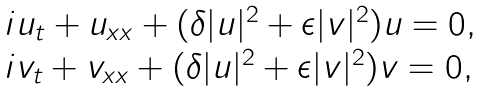Convert formula to latex. <formula><loc_0><loc_0><loc_500><loc_500>\begin{array} { l l } i u _ { t } + u _ { x x } + ( \delta | u | ^ { 2 } + \epsilon | v | ^ { 2 } ) u = 0 , \\ i v _ { t } + v _ { x x } + ( \delta | u | ^ { 2 } + \epsilon | v | ^ { 2 } ) v = 0 , \end{array}</formula> 